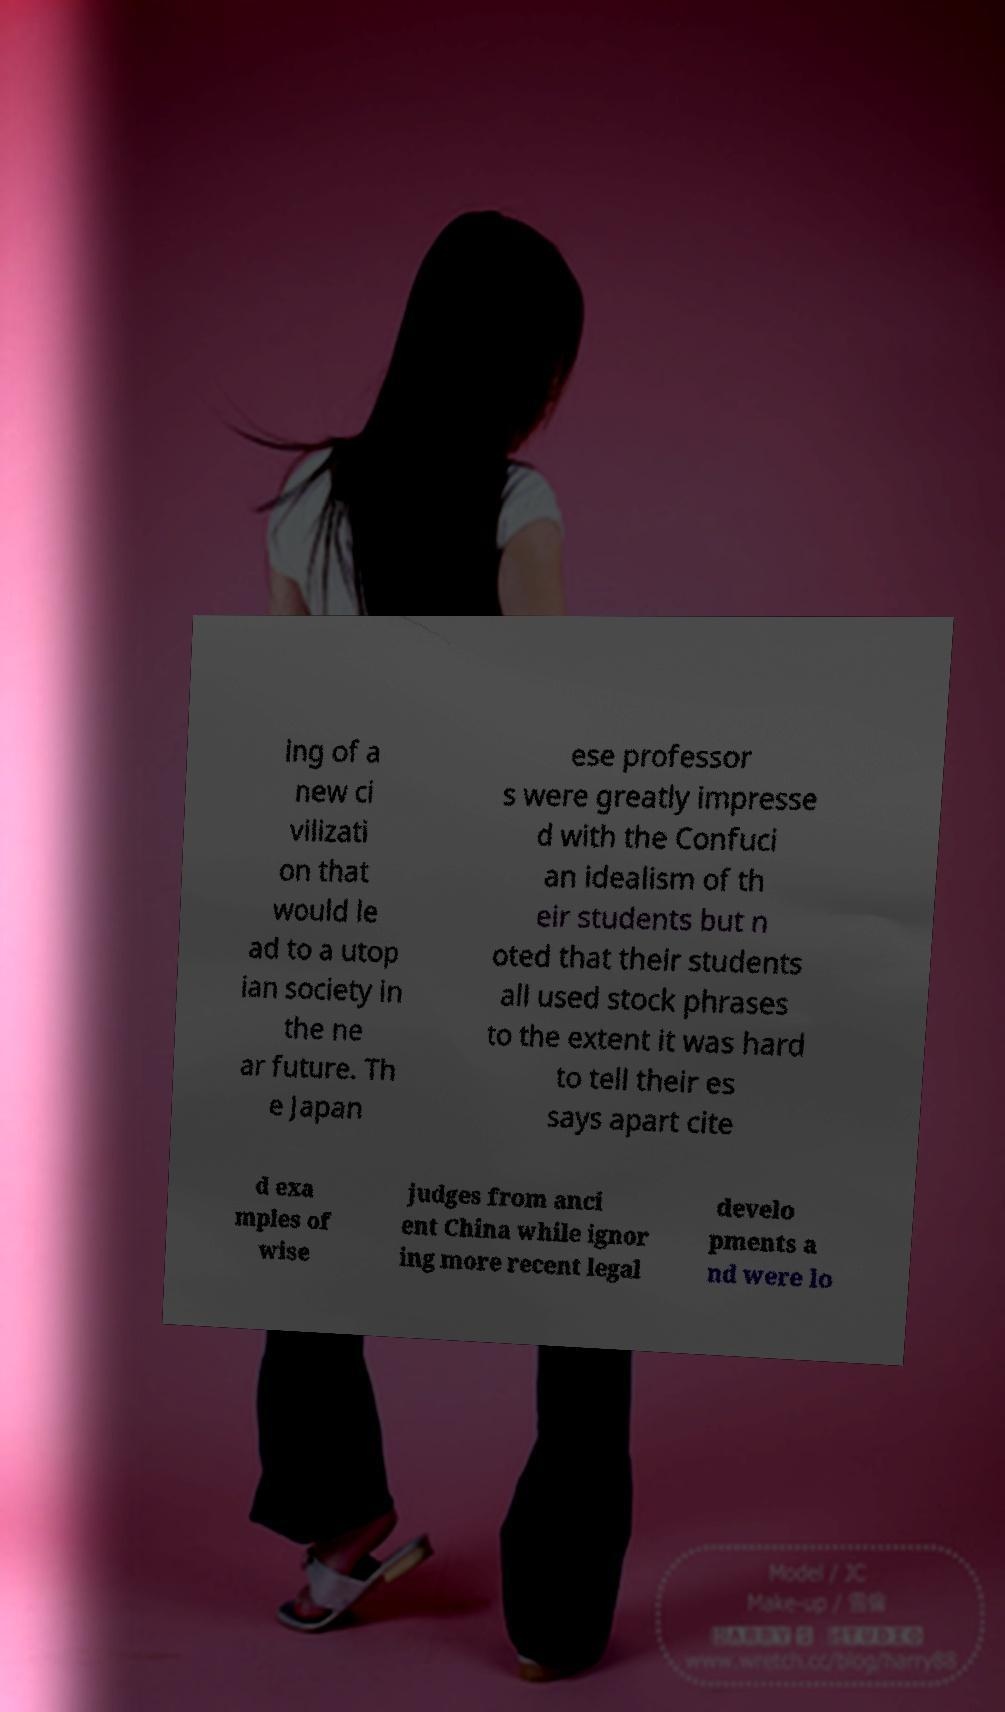Please read and relay the text visible in this image. What does it say? ing of a new ci vilizati on that would le ad to a utop ian society in the ne ar future. Th e Japan ese professor s were greatly impresse d with the Confuci an idealism of th eir students but n oted that their students all used stock phrases to the extent it was hard to tell their es says apart cite d exa mples of wise judges from anci ent China while ignor ing more recent legal develo pments a nd were lo 